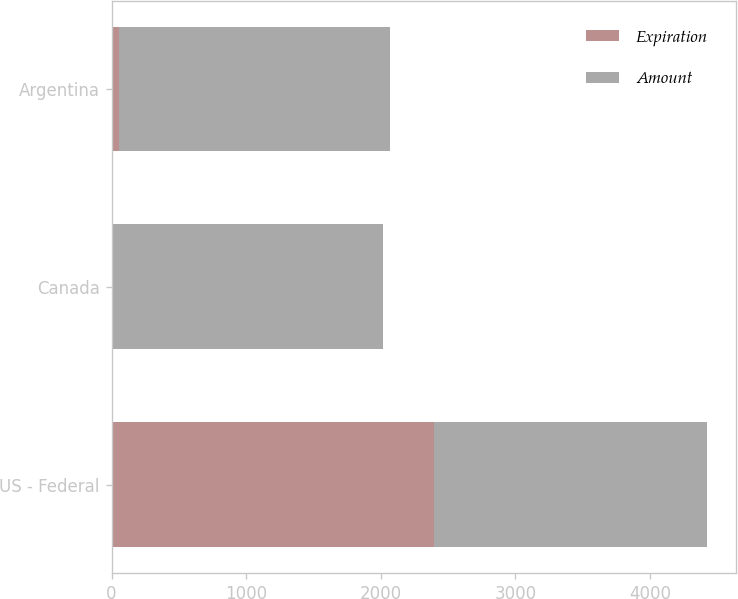Convert chart to OTSL. <chart><loc_0><loc_0><loc_500><loc_500><stacked_bar_chart><ecel><fcel>US - Federal<fcel>Canada<fcel>Argentina<nl><fcel>Expiration<fcel>2393<fcel>6<fcel>55<nl><fcel>Amount<fcel>2027<fcel>2014<fcel>2013<nl></chart> 